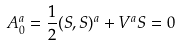Convert formula to latex. <formula><loc_0><loc_0><loc_500><loc_500>A _ { 0 } ^ { a } = \frac { 1 } { 2 } ( S , S ) ^ { a } + V ^ { a } S = 0</formula> 